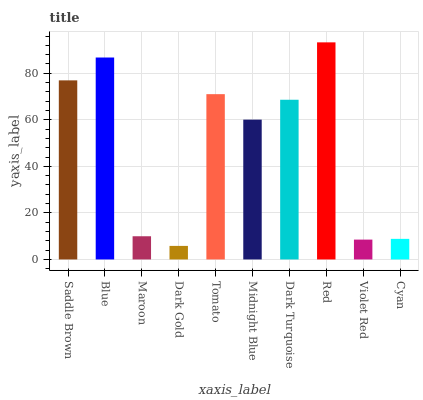Is Blue the minimum?
Answer yes or no. No. Is Blue the maximum?
Answer yes or no. No. Is Blue greater than Saddle Brown?
Answer yes or no. Yes. Is Saddle Brown less than Blue?
Answer yes or no. Yes. Is Saddle Brown greater than Blue?
Answer yes or no. No. Is Blue less than Saddle Brown?
Answer yes or no. No. Is Dark Turquoise the high median?
Answer yes or no. Yes. Is Midnight Blue the low median?
Answer yes or no. Yes. Is Red the high median?
Answer yes or no. No. Is Dark Gold the low median?
Answer yes or no. No. 